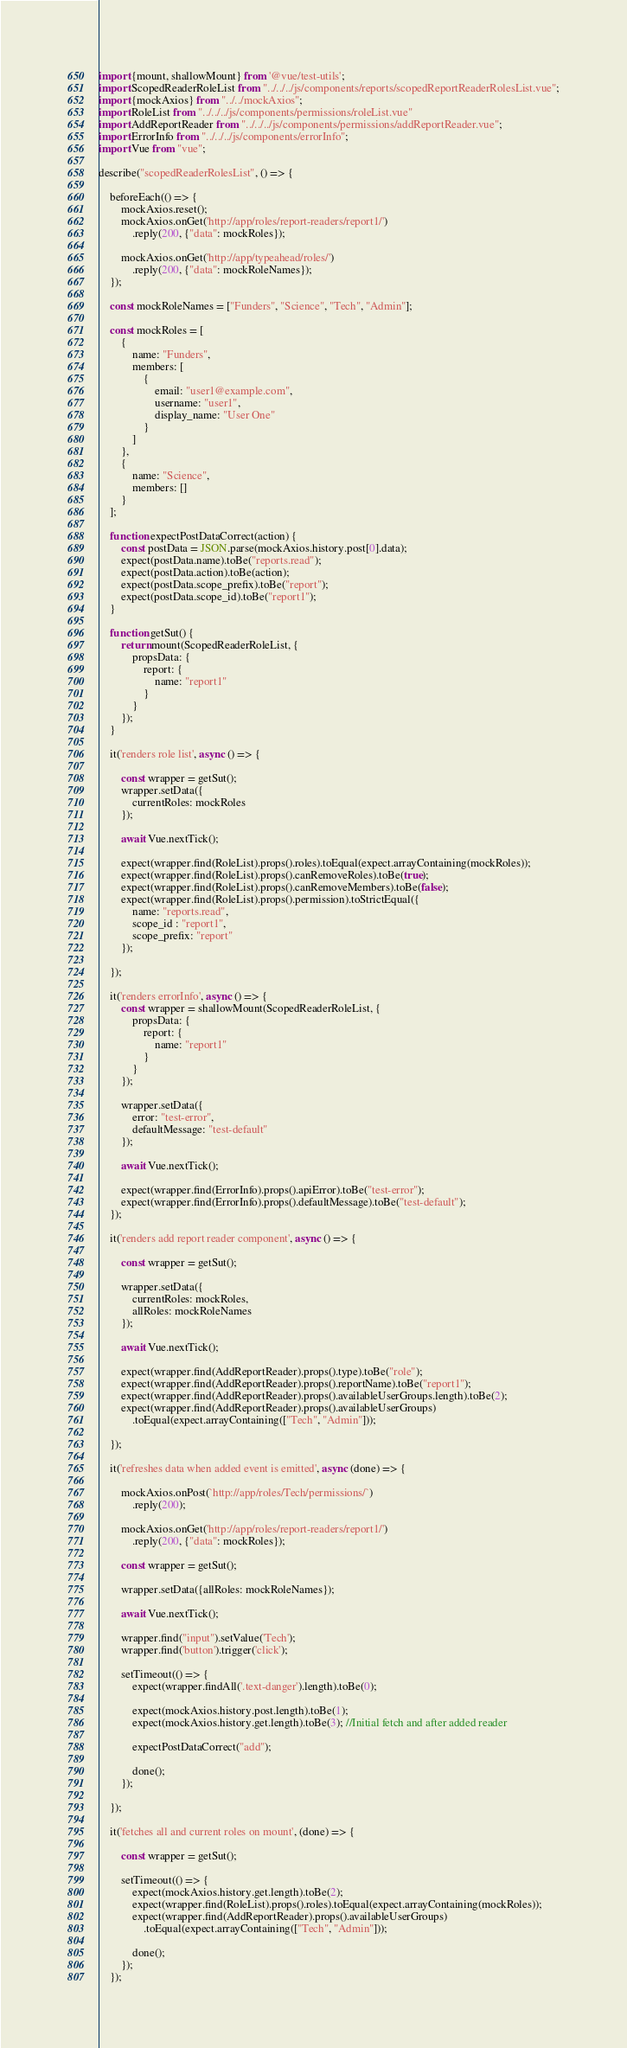Convert code to text. <code><loc_0><loc_0><loc_500><loc_500><_JavaScript_>import {mount, shallowMount} from '@vue/test-utils';
import ScopedReaderRoleList from "../../../js/components/reports/scopedReportReaderRolesList.vue";
import {mockAxios} from "../../mockAxios";
import RoleList from "../../../js/components/permissions/roleList.vue"
import AddReportReader from "../../../js/components/permissions/addReportReader.vue";
import ErrorInfo from "../../../js/components/errorInfo";
import Vue from "vue";

describe("scopedReaderRolesList", () => {

    beforeEach(() => {
        mockAxios.reset();
        mockAxios.onGet('http://app/roles/report-readers/report1/')
            .reply(200, {"data": mockRoles});

        mockAxios.onGet('http://app/typeahead/roles/')
            .reply(200, {"data": mockRoleNames});
    });

    const mockRoleNames = ["Funders", "Science", "Tech", "Admin"];

    const mockRoles = [
        {
            name: "Funders",
            members: [
                {
                    email: "user1@example.com",
                    username: "user1",
                    display_name: "User One"
                }
            ]
        },
        {
            name: "Science",
            members: []
        }
    ];

    function expectPostDataCorrect(action) {
        const postData = JSON.parse(mockAxios.history.post[0].data);
        expect(postData.name).toBe("reports.read");
        expect(postData.action).toBe(action);
        expect(postData.scope_prefix).toBe("report");
        expect(postData.scope_id).toBe("report1");
    }

    function getSut() {
        return mount(ScopedReaderRoleList, {
            propsData: {
                report: {
                    name: "report1"
                }
            }
        });
    }

    it('renders role list', async () => {

        const wrapper = getSut();
        wrapper.setData({
            currentRoles: mockRoles
        });

        await Vue.nextTick();

        expect(wrapper.find(RoleList).props().roles).toEqual(expect.arrayContaining(mockRoles));
        expect(wrapper.find(RoleList).props().canRemoveRoles).toBe(true);
        expect(wrapper.find(RoleList).props().canRemoveMembers).toBe(false);
        expect(wrapper.find(RoleList).props().permission).toStrictEqual({
            name: "reports.read",
            scope_id : "report1",
            scope_prefix: "report"
        });

    });

    it('renders errorInfo', async () => {
        const wrapper = shallowMount(ScopedReaderRoleList, {
            propsData: {
                report: {
                    name: "report1"
                }
            }
        });

        wrapper.setData({
            error: "test-error",
            defaultMessage: "test-default"
        });

        await Vue.nextTick();

        expect(wrapper.find(ErrorInfo).props().apiError).toBe("test-error");
        expect(wrapper.find(ErrorInfo).props().defaultMessage).toBe("test-default");
    });

    it('renders add report reader component', async () => {

        const wrapper = getSut();

        wrapper.setData({
            currentRoles: mockRoles,
            allRoles: mockRoleNames
        });

        await Vue.nextTick();

        expect(wrapper.find(AddReportReader).props().type).toBe("role");
        expect(wrapper.find(AddReportReader).props().reportName).toBe("report1");
        expect(wrapper.find(AddReportReader).props().availableUserGroups.length).toBe(2);
        expect(wrapper.find(AddReportReader).props().availableUserGroups)
            .toEqual(expect.arrayContaining(["Tech", "Admin"]));

    });

    it('refreshes data when added event is emitted', async (done) => {

        mockAxios.onPost(`http://app/roles/Tech/permissions/`)
            .reply(200);

        mockAxios.onGet('http://app/roles/report-readers/report1/')
            .reply(200, {"data": mockRoles});

        const wrapper = getSut();

        wrapper.setData({allRoles: mockRoleNames});

        await Vue.nextTick();

        wrapper.find("input").setValue('Tech');
        wrapper.find('button').trigger('click');

        setTimeout(() => {
            expect(wrapper.findAll('.text-danger').length).toBe(0);

            expect(mockAxios.history.post.length).toBe(1);
            expect(mockAxios.history.get.length).toBe(3); //Initial fetch and after added reader

            expectPostDataCorrect("add");

            done();
        });

    });

    it('fetches all and current roles on mount', (done) => {

        const wrapper = getSut();

        setTimeout(() => {
            expect(mockAxios.history.get.length).toBe(2);
            expect(wrapper.find(RoleList).props().roles).toEqual(expect.arrayContaining(mockRoles));
            expect(wrapper.find(AddReportReader).props().availableUserGroups)
                .toEqual(expect.arrayContaining(["Tech", "Admin"]));

            done();
        });
    });
</code> 